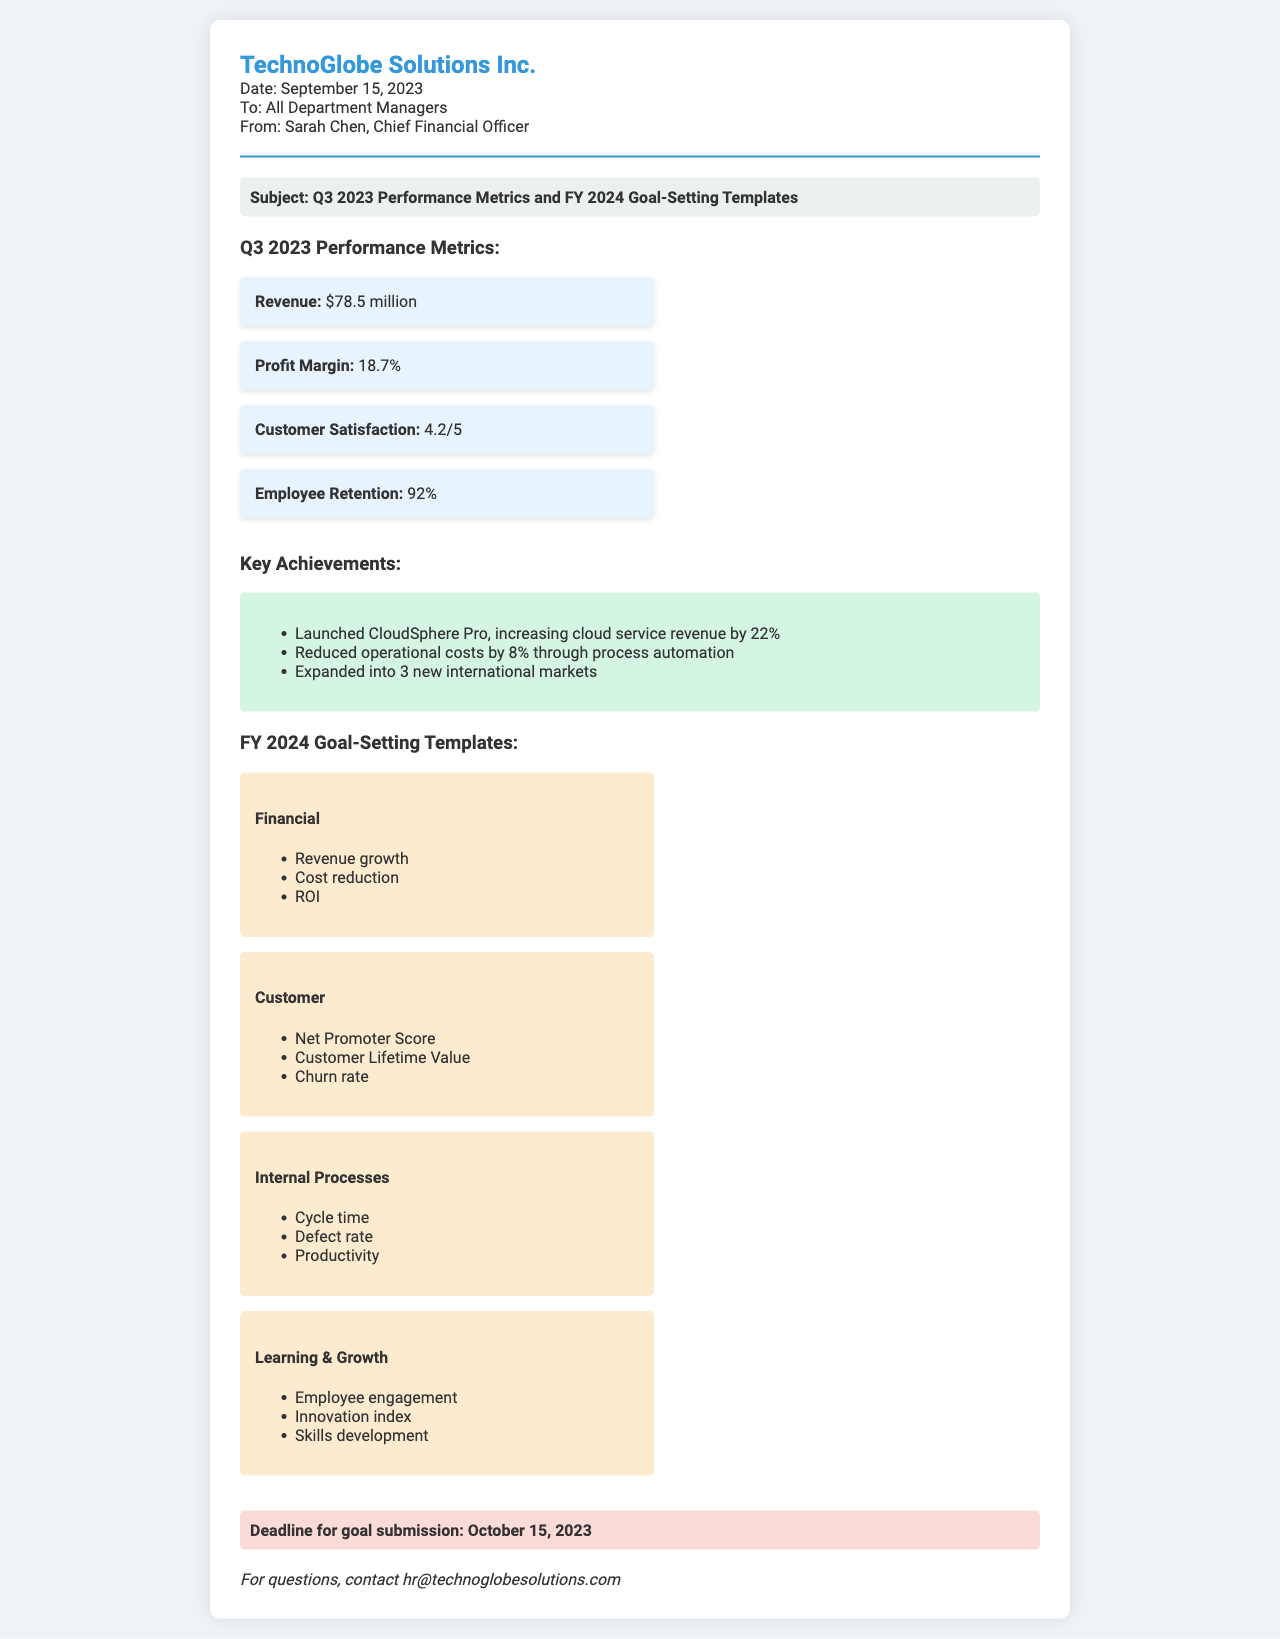What is the date of the fax? The date of the fax is explicitly stated in the document as September 15, 2023.
Answer: September 15, 2023 Who is the sender of the fax? The sender's name and title are provided in the document as Sarah Chen, Chief Financial Officer.
Answer: Sarah Chen, Chief Financial Officer What was the revenue for Q3 2023? The document lists the revenue figure for Q3 2023 as $78.5 million.
Answer: $78.5 million What is the deadline for goal submission? The document specifies the deadline for goal submission as October 15, 2023.
Answer: October 15, 2023 What is one of the key achievements mentioned? The key achievements section lists multiple accomplishments, one being the launch of CloudSphere Pro, which increased cloud service revenue.
Answer: Launched CloudSphere Pro What is the profit margin reported? The document states the profit margin for Q3 2023 as 18.7%.
Answer: 18.7% How many new markets was the company expanded into? The document indicates that the company expanded into 3 new international markets.
Answer: 3 What template category includes "Employee engagement"? The "Learning & Growth" template category includes "Employee engagement" as one of its objectives.
Answer: Learning & Growth How was customer satisfaction rated? The document records customer satisfaction with a rating of 4.2 out of 5.
Answer: 4.2/5 